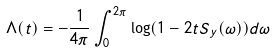Convert formula to latex. <formula><loc_0><loc_0><loc_500><loc_500>\Lambda ( t ) = - \frac { 1 } { 4 \pi } \int _ { 0 } ^ { 2 \pi } \log ( 1 - 2 t S _ { y } ( \omega ) ) d \omega</formula> 